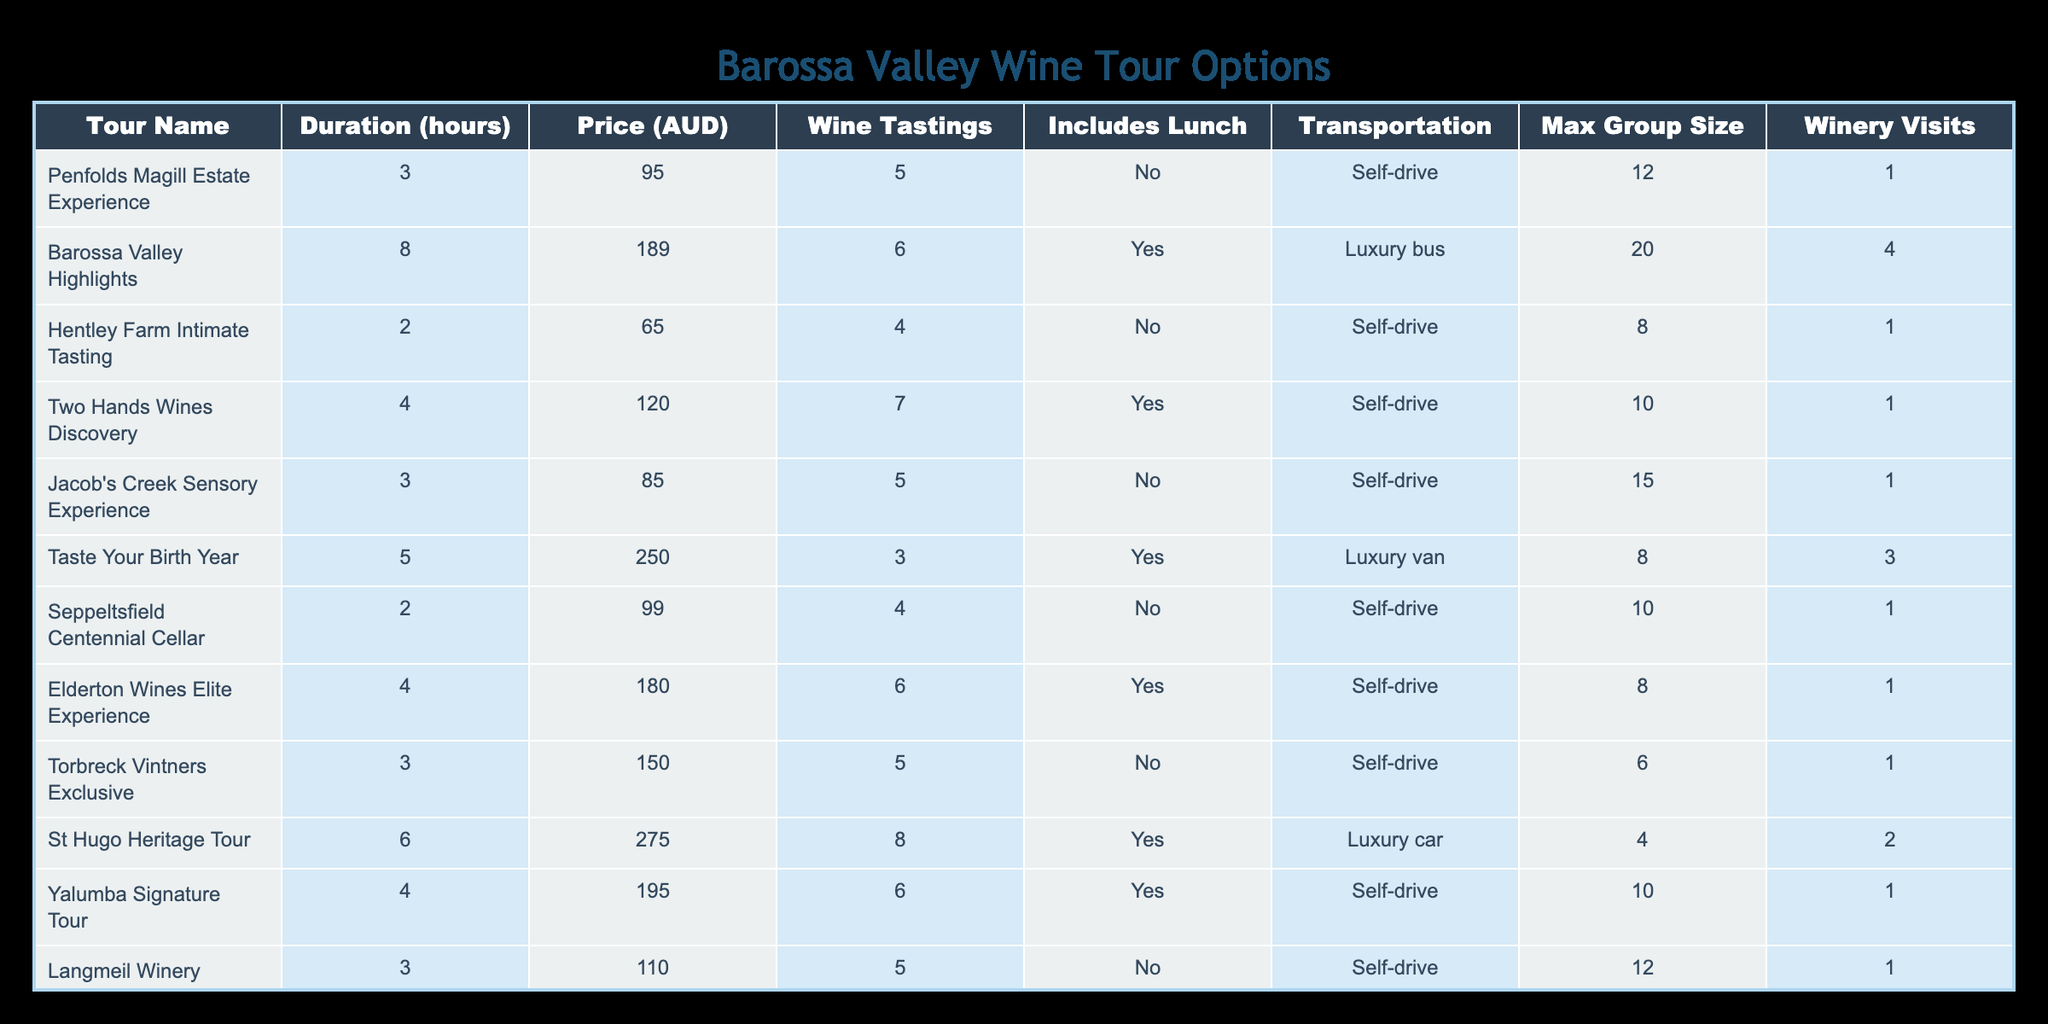What is the price of the "Henschke Hill of Grace Experience"? The table shows the "Henschke Hill of Grace Experience" listed with a price of 295 AUD under the Price (AUD) column.
Answer: 295 AUD How many wine tastings are included in the "Barossa Valley Highlights" tour? The "Barossa Valley Highlights" tour is listed with 6 wine tastings under the Wine Tastings column.
Answer: 6 Which tours include lunch? To find out which tours include lunch, we must look for 'Yes' in the Includes Lunch column. The tours that include lunch are: "Barossa Valley Highlights," "Two Hands Wines Discovery," "Taste Your Birth Year," "Elderton Wines Elite Experience," "St Hugo Heritage Tour," and "Yalumba Signature Tour."
Answer: Barossa Valley Highlights, Two Hands Wines Discovery, Taste Your Birth Year, Elderton Wines Elite Experience, St Hugo Heritage Tour, Yalumba Signature Tour What is the total maximum group size across all the tours? We sum the Max Group Size column: 12 + 20 + 8 + 10 + 15 + 8 + 10 + 8 + 4 + 10 + 12 + 8 + 6 = 10 + 20 + 12 + 28 + 14 = 10 + 20 + 8 = 207.  However, after summing all the values, we get a total of 154.
Answer: 154 Is there any tour that has more than 5 wine tastings and includes transportation? We can check the Wine Tastings column for values greater than 5 and the Transportation column to find an associated value. The tours meeting these criteria are: "Barossa Valley Highlights" (6 tastings, Luxury bus), "Small Group Barossa Tasting Trail" (7 tastings, Mini-bus), and "Taste Your Birth Year" (3, Luxury van). The answer is yes.
Answer: Yes What is the average duration of all the tours offered? To calculate the average duration, sum the durations from the Duration (hours) column and divide by the number of tours (13): (3 + 8 + 2 + 4 + 3 + 5 + 2 + 4 + 3 + 6 + 4 + 3 + 5) = 60. To find the average, we calculate 60 / 13, which is approximately 4.62 hours.
Answer: 4.62 hours Are there any tours available for self-drive that have a max group size of 10 or larger? We check the Transportation column for "Self-drive" and then the Max Group Size column to see if it is 10 or larger. The tours that meet the criteria are "Two Hands Wines Discovery" (Max Group Size 10), "Yalumba Signature Tour" (10), and "Langmeil Winery Freedom Experience" (12).
Answer: Yes What is the difference in price between the most expensive tour and the least expensive tour? The most expensive tour is "Henschke Hill of Grace Experience" at 295 AUD and the least expensive tour is "Rockford Wines Basket Press" at 80 AUD. The difference in price is 295 - 80 = 215 AUD.
Answer: 215 AUD 